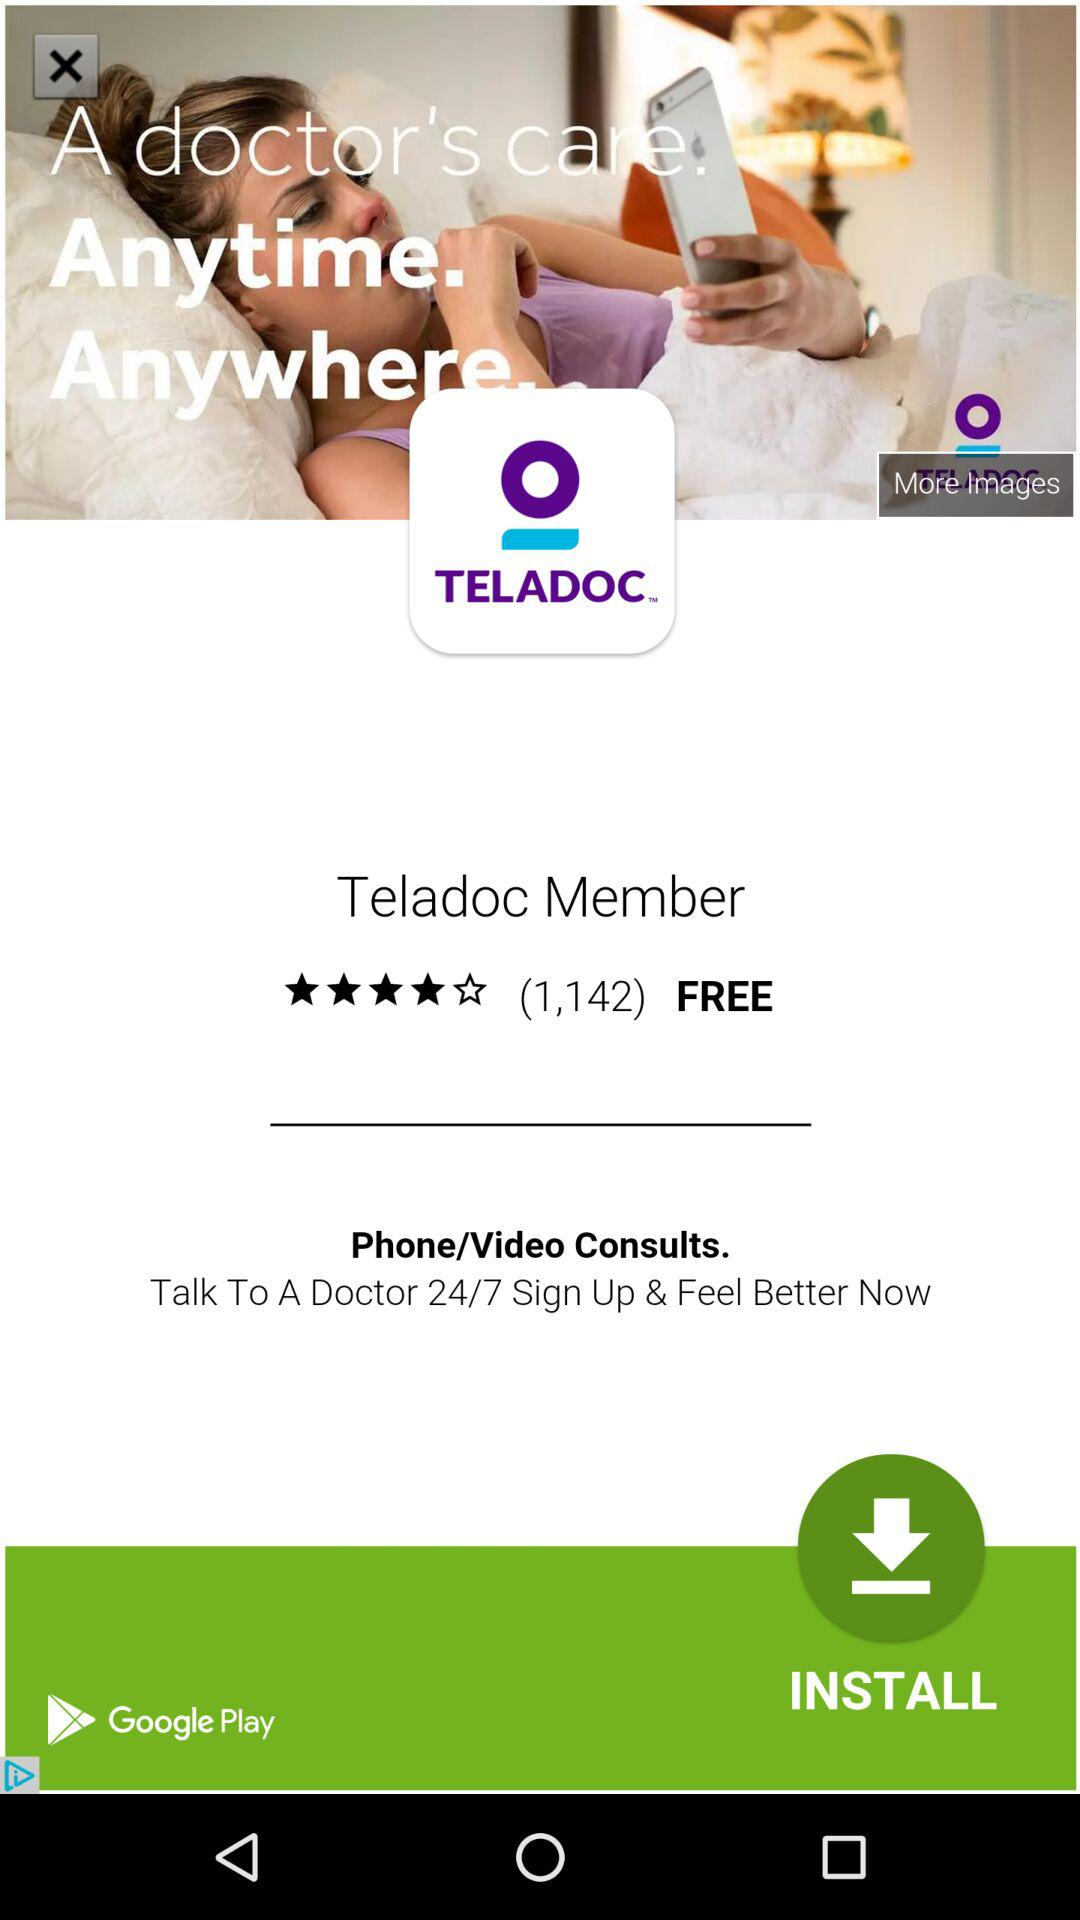What is the rating? The rating is 4 stars. 